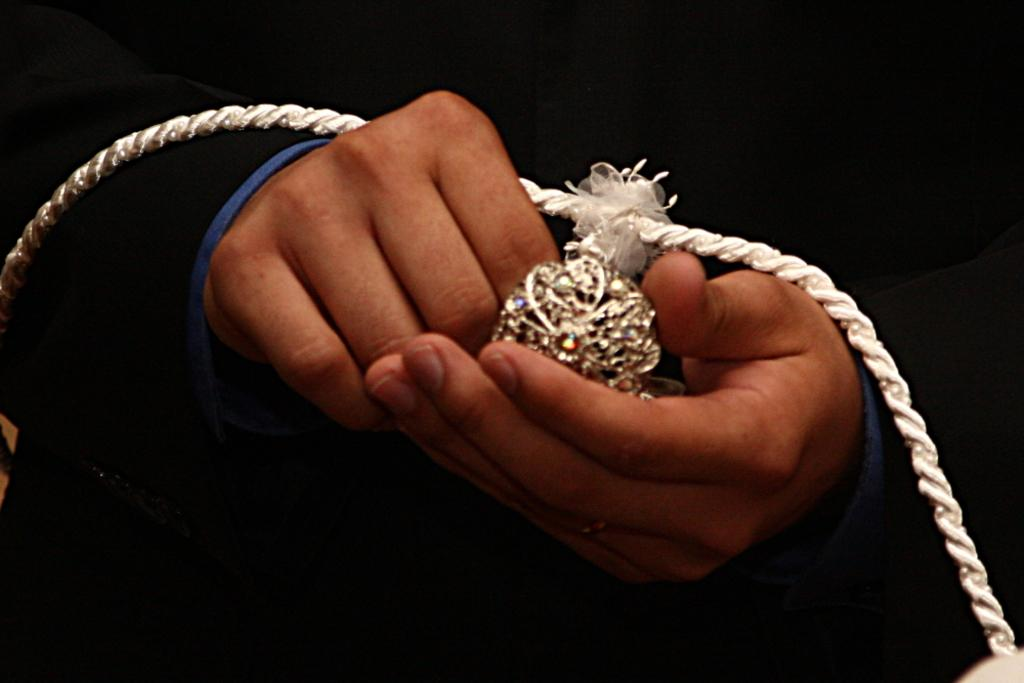Who or what is the main subject in the image? There is a person in the center of the image. What is the person holding in his hands? The person is holding a locket in his hands. Where is the drain located in the image? There is no drain present in the image. Can you see any deer in the image? There are no deer present in the image. 